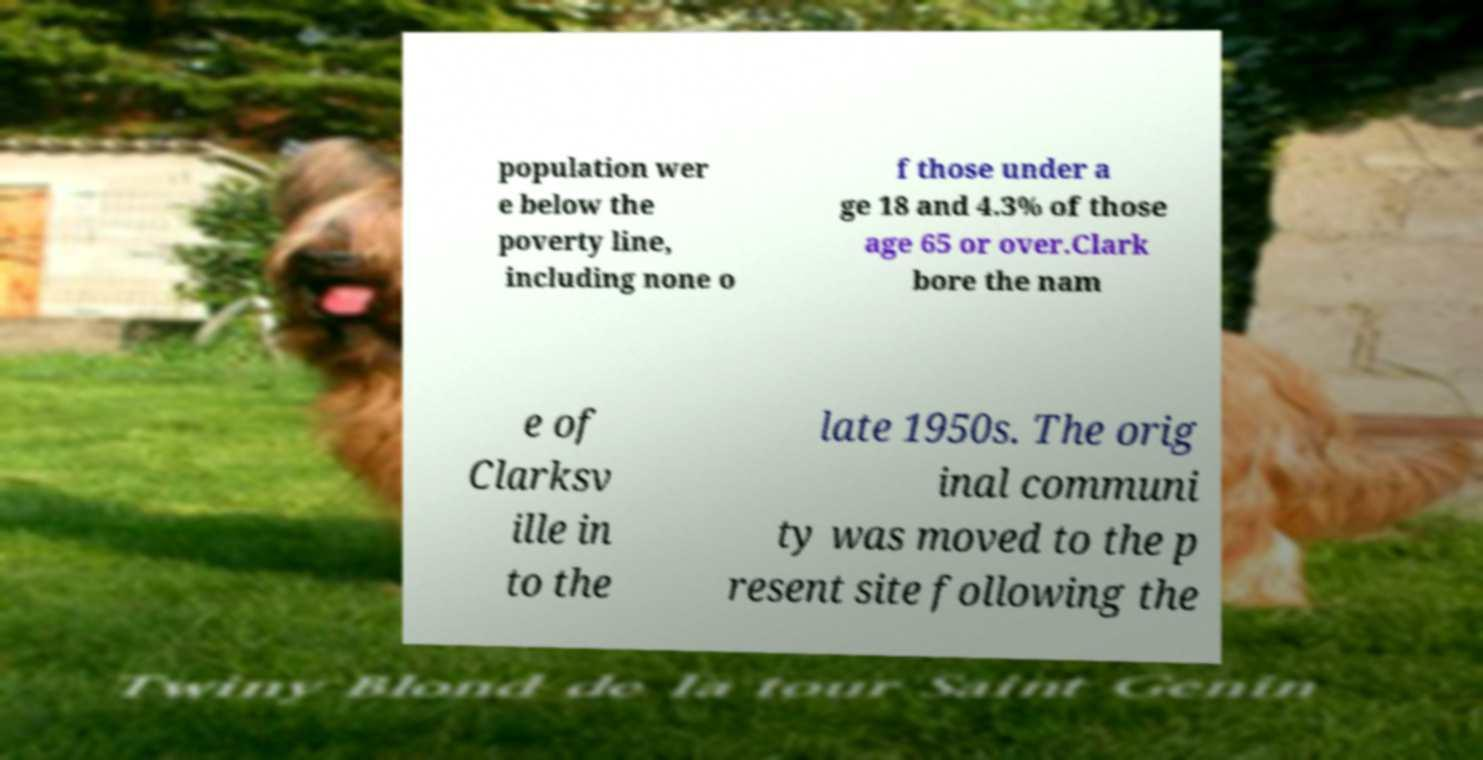Please identify and transcribe the text found in this image. population wer e below the poverty line, including none o f those under a ge 18 and 4.3% of those age 65 or over.Clark bore the nam e of Clarksv ille in to the late 1950s. The orig inal communi ty was moved to the p resent site following the 